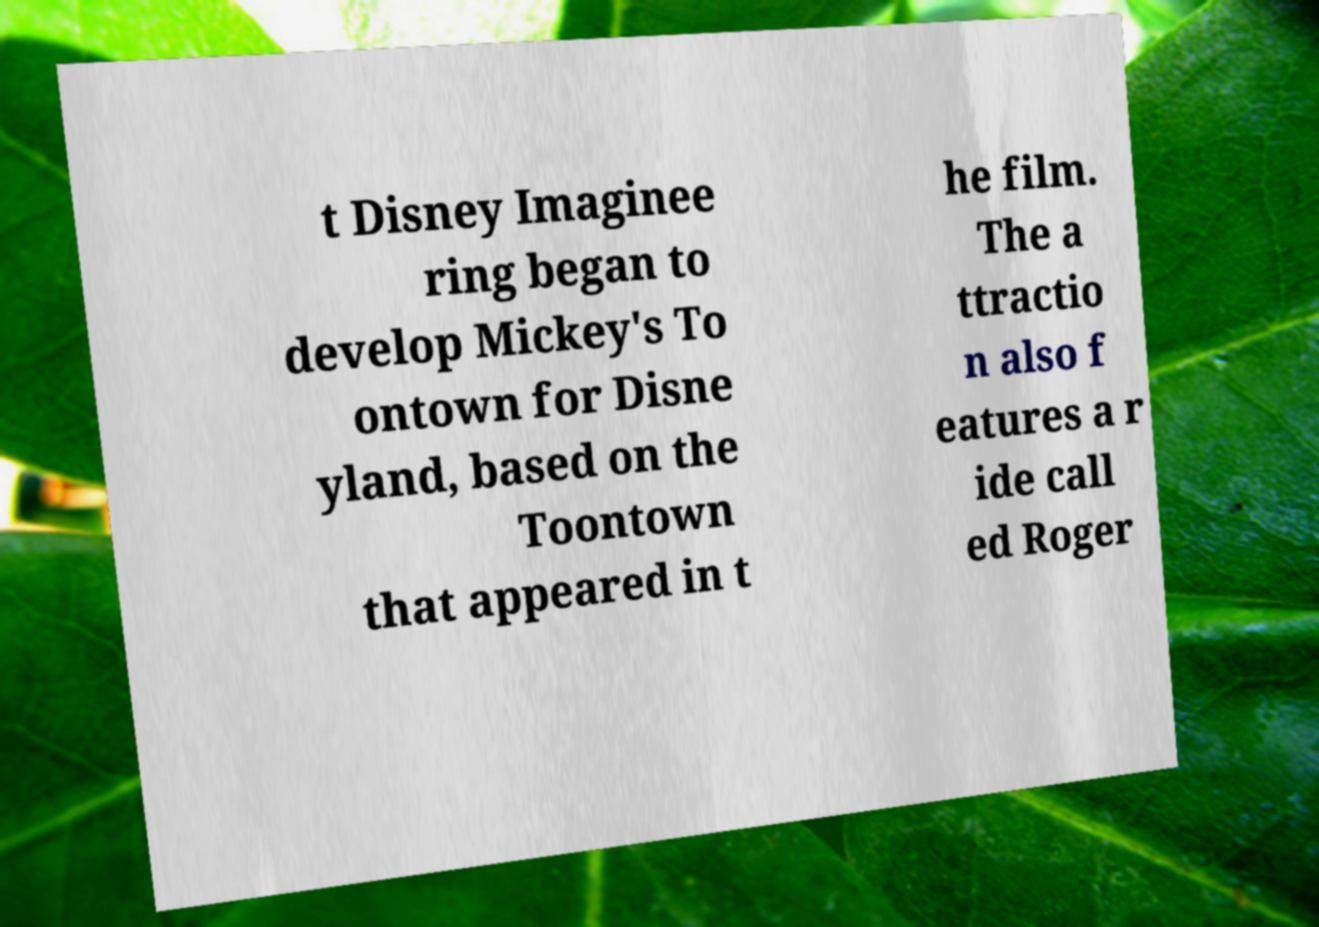Can you accurately transcribe the text from the provided image for me? t Disney Imaginee ring began to develop Mickey's To ontown for Disne yland, based on the Toontown that appeared in t he film. The a ttractio n also f eatures a r ide call ed Roger 